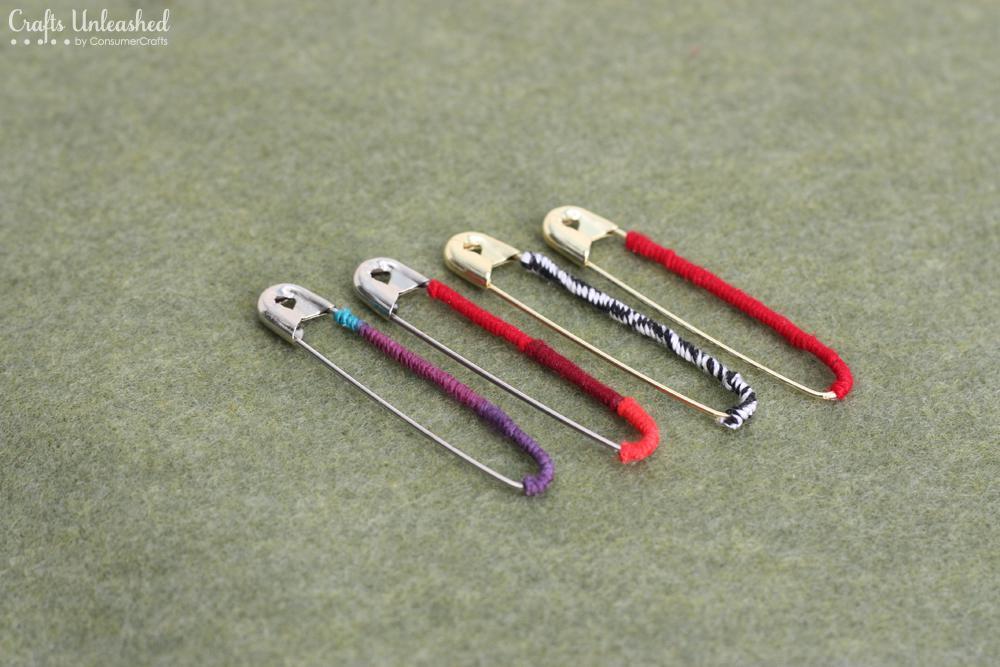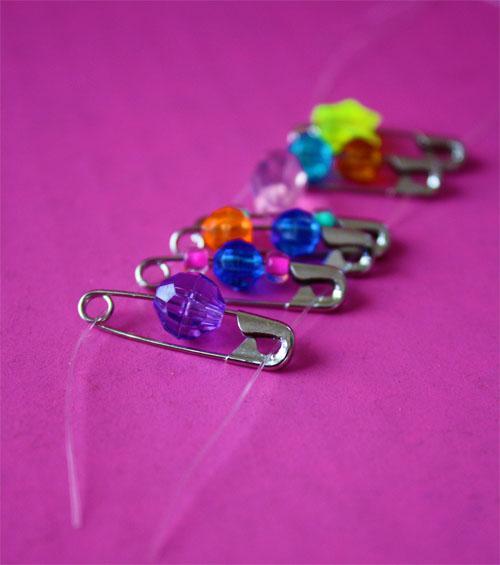The first image is the image on the left, the second image is the image on the right. Assess this claim about the two images: "An image shows exactly six safety pins strung with beads, displayed on purple.". Correct or not? Answer yes or no. Yes. The first image is the image on the left, the second image is the image on the right. Examine the images to the left and right. Is the description "The left image has four safety pins." accurate? Answer yes or no. Yes. 